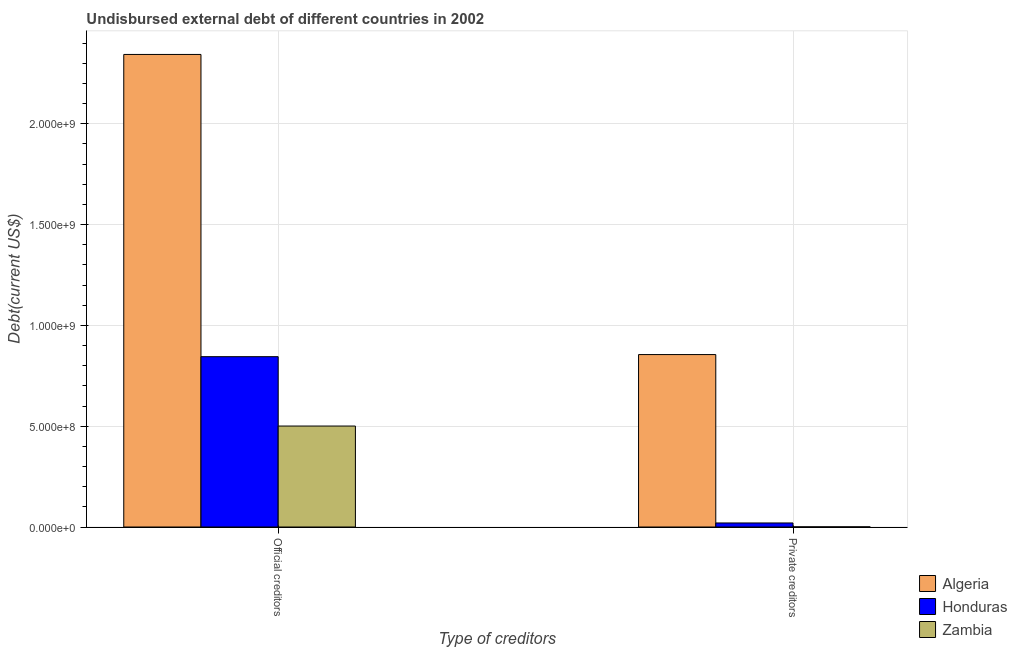How many different coloured bars are there?
Your response must be concise. 3. Are the number of bars on each tick of the X-axis equal?
Make the answer very short. Yes. How many bars are there on the 2nd tick from the left?
Give a very brief answer. 3. What is the label of the 2nd group of bars from the left?
Give a very brief answer. Private creditors. What is the undisbursed external debt of private creditors in Honduras?
Give a very brief answer. 2.01e+07. Across all countries, what is the maximum undisbursed external debt of private creditors?
Make the answer very short. 8.55e+08. Across all countries, what is the minimum undisbursed external debt of official creditors?
Your response must be concise. 5.01e+08. In which country was the undisbursed external debt of private creditors maximum?
Give a very brief answer. Algeria. In which country was the undisbursed external debt of official creditors minimum?
Your answer should be very brief. Zambia. What is the total undisbursed external debt of private creditors in the graph?
Give a very brief answer. 8.76e+08. What is the difference between the undisbursed external debt of official creditors in Zambia and that in Algeria?
Provide a short and direct response. -1.84e+09. What is the difference between the undisbursed external debt of private creditors in Zambia and the undisbursed external debt of official creditors in Honduras?
Ensure brevity in your answer.  -8.44e+08. What is the average undisbursed external debt of official creditors per country?
Offer a very short reply. 1.23e+09. What is the difference between the undisbursed external debt of official creditors and undisbursed external debt of private creditors in Algeria?
Your answer should be very brief. 1.49e+09. In how many countries, is the undisbursed external debt of official creditors greater than 100000000 US$?
Provide a short and direct response. 3. What is the ratio of the undisbursed external debt of official creditors in Zambia to that in Algeria?
Your answer should be compact. 0.21. What does the 2nd bar from the left in Private creditors represents?
Ensure brevity in your answer.  Honduras. What does the 2nd bar from the right in Official creditors represents?
Your answer should be very brief. Honduras. Are all the bars in the graph horizontal?
Give a very brief answer. No. How many countries are there in the graph?
Your answer should be compact. 3. Are the values on the major ticks of Y-axis written in scientific E-notation?
Provide a succinct answer. Yes. Does the graph contain any zero values?
Your answer should be compact. No. Where does the legend appear in the graph?
Make the answer very short. Bottom right. How many legend labels are there?
Provide a short and direct response. 3. How are the legend labels stacked?
Offer a terse response. Vertical. What is the title of the graph?
Make the answer very short. Undisbursed external debt of different countries in 2002. What is the label or title of the X-axis?
Ensure brevity in your answer.  Type of creditors. What is the label or title of the Y-axis?
Provide a short and direct response. Debt(current US$). What is the Debt(current US$) in Algeria in Official creditors?
Offer a very short reply. 2.34e+09. What is the Debt(current US$) of Honduras in Official creditors?
Your answer should be very brief. 8.45e+08. What is the Debt(current US$) in Zambia in Official creditors?
Offer a very short reply. 5.01e+08. What is the Debt(current US$) in Algeria in Private creditors?
Your answer should be compact. 8.55e+08. What is the Debt(current US$) in Honduras in Private creditors?
Ensure brevity in your answer.  2.01e+07. What is the Debt(current US$) of Zambia in Private creditors?
Your answer should be compact. 8.09e+05. Across all Type of creditors, what is the maximum Debt(current US$) of Algeria?
Offer a very short reply. 2.34e+09. Across all Type of creditors, what is the maximum Debt(current US$) in Honduras?
Your response must be concise. 8.45e+08. Across all Type of creditors, what is the maximum Debt(current US$) in Zambia?
Provide a short and direct response. 5.01e+08. Across all Type of creditors, what is the minimum Debt(current US$) in Algeria?
Give a very brief answer. 8.55e+08. Across all Type of creditors, what is the minimum Debt(current US$) of Honduras?
Provide a short and direct response. 2.01e+07. Across all Type of creditors, what is the minimum Debt(current US$) of Zambia?
Your response must be concise. 8.09e+05. What is the total Debt(current US$) in Algeria in the graph?
Offer a very short reply. 3.20e+09. What is the total Debt(current US$) of Honduras in the graph?
Offer a terse response. 8.65e+08. What is the total Debt(current US$) in Zambia in the graph?
Ensure brevity in your answer.  5.01e+08. What is the difference between the Debt(current US$) of Algeria in Official creditors and that in Private creditors?
Offer a very short reply. 1.49e+09. What is the difference between the Debt(current US$) in Honduras in Official creditors and that in Private creditors?
Offer a very short reply. 8.25e+08. What is the difference between the Debt(current US$) in Zambia in Official creditors and that in Private creditors?
Keep it short and to the point. 5.00e+08. What is the difference between the Debt(current US$) in Algeria in Official creditors and the Debt(current US$) in Honduras in Private creditors?
Provide a short and direct response. 2.32e+09. What is the difference between the Debt(current US$) of Algeria in Official creditors and the Debt(current US$) of Zambia in Private creditors?
Provide a succinct answer. 2.34e+09. What is the difference between the Debt(current US$) of Honduras in Official creditors and the Debt(current US$) of Zambia in Private creditors?
Your response must be concise. 8.44e+08. What is the average Debt(current US$) in Algeria per Type of creditors?
Your answer should be very brief. 1.60e+09. What is the average Debt(current US$) in Honduras per Type of creditors?
Make the answer very short. 4.32e+08. What is the average Debt(current US$) of Zambia per Type of creditors?
Your answer should be compact. 2.51e+08. What is the difference between the Debt(current US$) of Algeria and Debt(current US$) of Honduras in Official creditors?
Give a very brief answer. 1.50e+09. What is the difference between the Debt(current US$) of Algeria and Debt(current US$) of Zambia in Official creditors?
Your answer should be very brief. 1.84e+09. What is the difference between the Debt(current US$) in Honduras and Debt(current US$) in Zambia in Official creditors?
Keep it short and to the point. 3.44e+08. What is the difference between the Debt(current US$) of Algeria and Debt(current US$) of Honduras in Private creditors?
Your answer should be compact. 8.35e+08. What is the difference between the Debt(current US$) in Algeria and Debt(current US$) in Zambia in Private creditors?
Your answer should be compact. 8.54e+08. What is the difference between the Debt(current US$) in Honduras and Debt(current US$) in Zambia in Private creditors?
Give a very brief answer. 1.92e+07. What is the ratio of the Debt(current US$) of Algeria in Official creditors to that in Private creditors?
Ensure brevity in your answer.  2.74. What is the ratio of the Debt(current US$) of Honduras in Official creditors to that in Private creditors?
Ensure brevity in your answer.  42.11. What is the ratio of the Debt(current US$) of Zambia in Official creditors to that in Private creditors?
Make the answer very short. 618.89. What is the difference between the highest and the second highest Debt(current US$) in Algeria?
Your answer should be compact. 1.49e+09. What is the difference between the highest and the second highest Debt(current US$) of Honduras?
Provide a succinct answer. 8.25e+08. What is the difference between the highest and the second highest Debt(current US$) in Zambia?
Give a very brief answer. 5.00e+08. What is the difference between the highest and the lowest Debt(current US$) in Algeria?
Make the answer very short. 1.49e+09. What is the difference between the highest and the lowest Debt(current US$) of Honduras?
Provide a succinct answer. 8.25e+08. What is the difference between the highest and the lowest Debt(current US$) in Zambia?
Provide a short and direct response. 5.00e+08. 